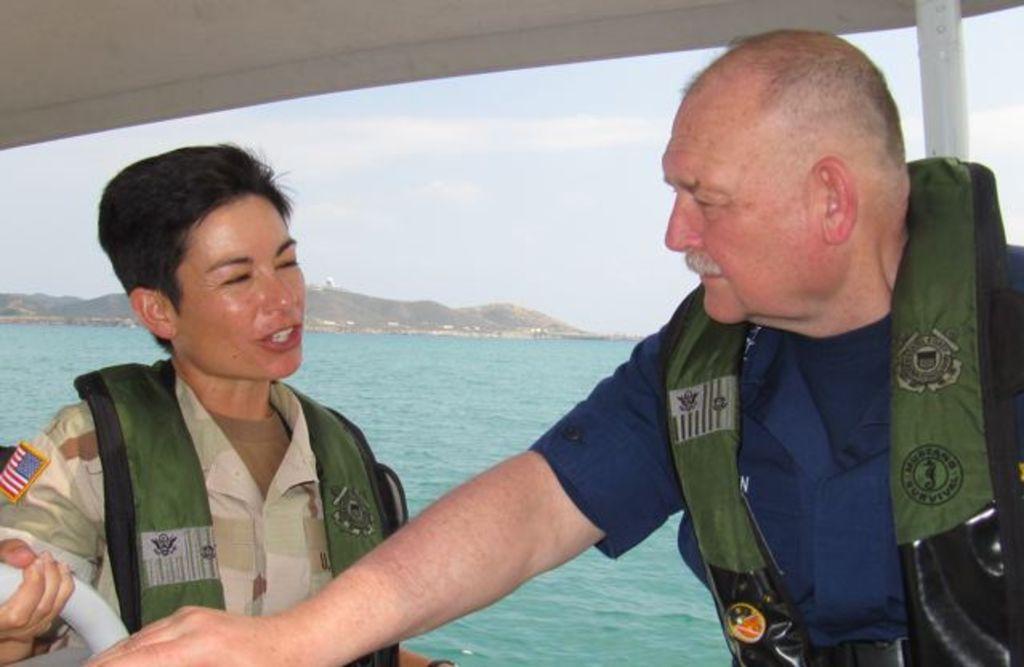Could you give a brief overview of what you see in this image? In this picture we can see the sky, hills and the water. We can see the white stands. We can see the people wearing life jackets and it seems like they are discussing something. We can see a person on the left side is holding a white stand. 